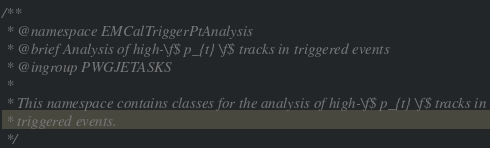Convert code to text. <code><loc_0><loc_0><loc_500><loc_500><_C_>/**
 * @namespace EMCalTriggerPtAnalysis
 * @brief Analysis of high-\f$ p_{t} \f$ tracks in triggered events
 * @ingroup PWGJETASKS
 *
 * This namespace contains classes for the analysis of high-\f$ p_{t} \f$ tracks in
 * triggered events.
 */
</code> 